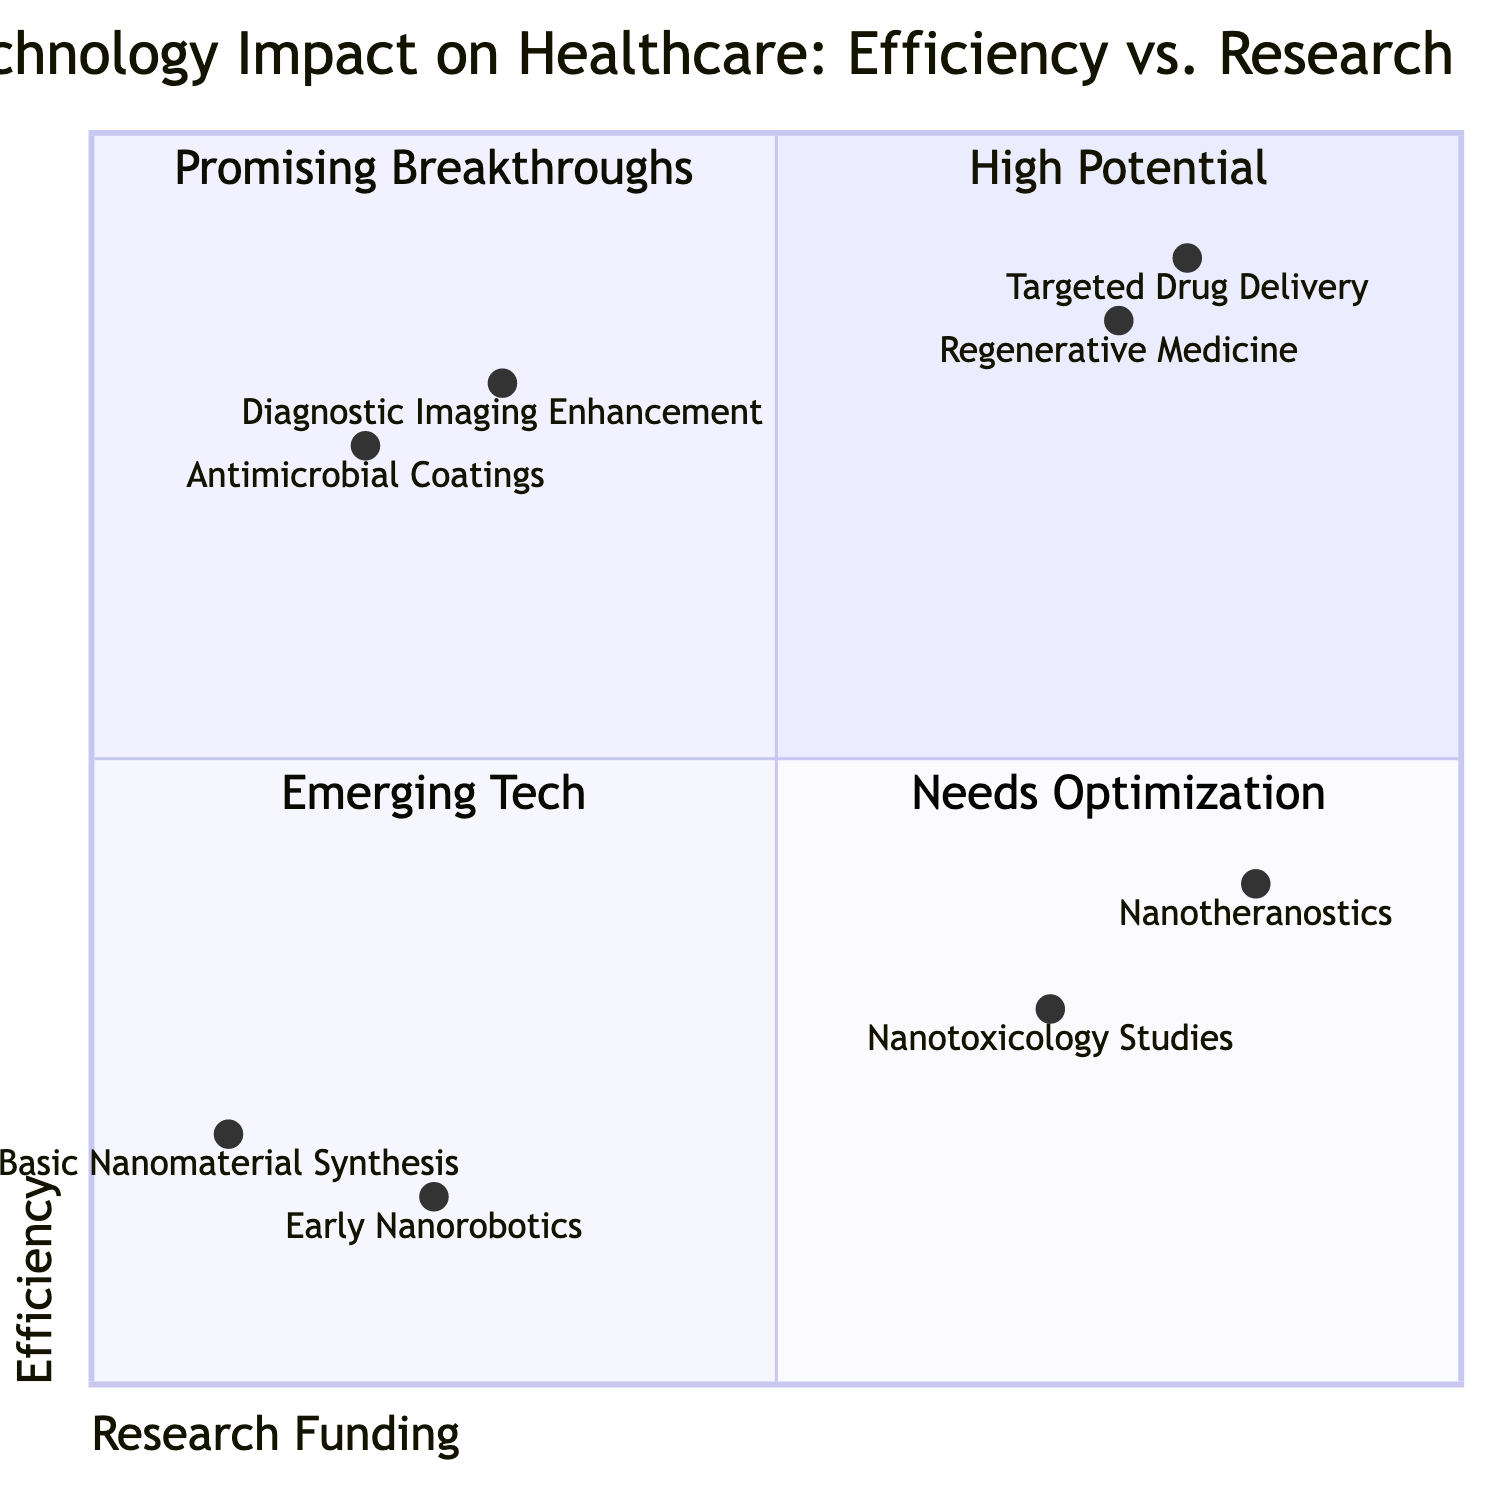What is the highest efficiency in the diagram? The highest efficiency among the listed technologies is 0.9, which corresponds to Targeted Drug Delivery.
Answer: 0.9 Which technology is positioned in the "Needs Optimization" quadrant? The "Needs Optimization" quadrant, which corresponds to low research funding and low efficiency, includes Basic Nanomaterial Synthesis and Early Nanorobotics.
Answer: Basic Nanomaterial Synthesis, Early Nanorobotics How many technologies are in the "Promising Breakthroughs" quadrant? The "Promising Breakthroughs" quadrant contains two technologies: Targeted Drug Delivery and Regenerative Medicine.
Answer: 2 Which technology has the lowest research funding? The technology with the lowest research funding is Basic Nanomaterial Synthesis, with a value of 0.1 on the x-axis.
Answer: Basic Nanomaterial Synthesis Which quadrant contains the most efficient technology? The "High Potential" quadrant contains the most efficient technology, which is Targeted Drug Delivery at an efficiency value of 0.9.
Answer: High Potential What is the efficiency of Nanotoxicology Studies? The efficiency of Nanotoxicology Studies is 0.3, as denoted on the y-axis in the diagram.
Answer: 0.3 Which technology is categorized under "Emerging Tech"? The "Emerging Tech" quadrant includes Basic Nanomaterial Synthesis and Early Nanorobotics, characterized by low efficiency and research funding.
Answer: Basic Nanomaterial Synthesis, Early Nanorobotics How many technologies fall under the category of high research funding? Four technologies are identified under high research funding; these include Targeted Drug Delivery, Regenerative Medicine, Nanotoxicology Studies, and Nanotheranostics.
Answer: 4 